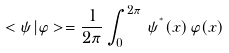<formula> <loc_0><loc_0><loc_500><loc_500>< \psi | \varphi > = \frac { 1 } { 2 \pi } \int _ { 0 } ^ { 2 \pi } \, \psi ^ { ^ { * } } ( x ) \, \varphi ( x )</formula> 